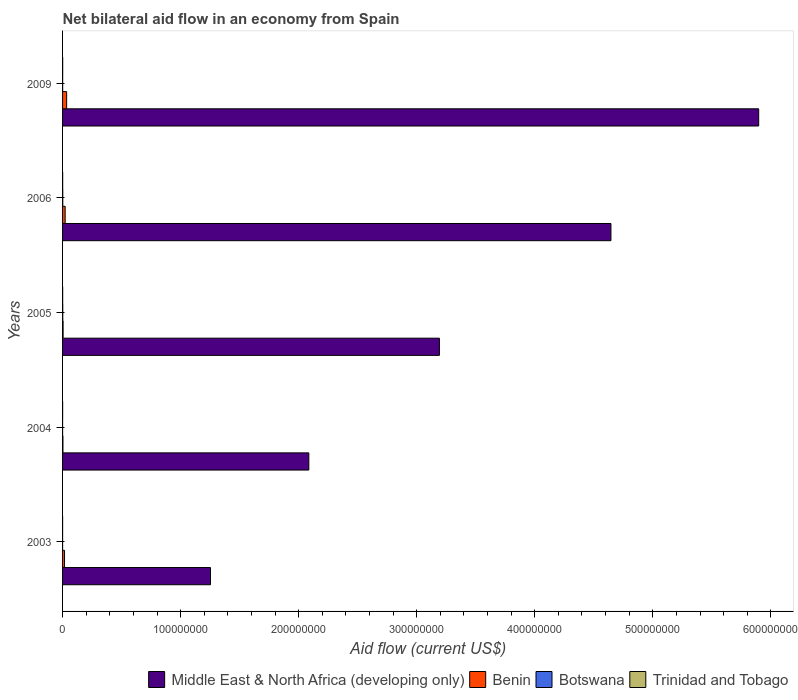How many different coloured bars are there?
Give a very brief answer. 4. How many bars are there on the 3rd tick from the bottom?
Ensure brevity in your answer.  4. What is the net bilateral aid flow in Middle East & North Africa (developing only) in 2003?
Give a very brief answer. 1.25e+08. Across all years, what is the maximum net bilateral aid flow in Botswana?
Your answer should be compact. 1.50e+05. Across all years, what is the minimum net bilateral aid flow in Middle East & North Africa (developing only)?
Give a very brief answer. 1.25e+08. In which year was the net bilateral aid flow in Benin maximum?
Keep it short and to the point. 2009. In which year was the net bilateral aid flow in Benin minimum?
Your answer should be very brief. 2004. What is the total net bilateral aid flow in Middle East & North Africa (developing only) in the graph?
Your answer should be very brief. 1.71e+09. What is the difference between the net bilateral aid flow in Trinidad and Tobago in 2009 and the net bilateral aid flow in Benin in 2003?
Offer a very short reply. -1.58e+06. What is the average net bilateral aid flow in Benin per year?
Provide a short and direct response. 1.61e+06. In the year 2009, what is the difference between the net bilateral aid flow in Middle East & North Africa (developing only) and net bilateral aid flow in Botswana?
Your answer should be compact. 5.90e+08. In how many years, is the net bilateral aid flow in Trinidad and Tobago greater than 360000000 US$?
Provide a short and direct response. 0. What is the ratio of the net bilateral aid flow in Middle East & North Africa (developing only) in 2003 to that in 2006?
Make the answer very short. 0.27. Is the difference between the net bilateral aid flow in Middle East & North Africa (developing only) in 2003 and 2009 greater than the difference between the net bilateral aid flow in Botswana in 2003 and 2009?
Provide a succinct answer. No. What is the difference between the highest and the lowest net bilateral aid flow in Trinidad and Tobago?
Keep it short and to the point. 6.00e+04. Is it the case that in every year, the sum of the net bilateral aid flow in Trinidad and Tobago and net bilateral aid flow in Botswana is greater than the sum of net bilateral aid flow in Middle East & North Africa (developing only) and net bilateral aid flow in Benin?
Ensure brevity in your answer.  No. What does the 2nd bar from the top in 2003 represents?
Provide a short and direct response. Botswana. What does the 2nd bar from the bottom in 2006 represents?
Your response must be concise. Benin. Is it the case that in every year, the sum of the net bilateral aid flow in Benin and net bilateral aid flow in Botswana is greater than the net bilateral aid flow in Trinidad and Tobago?
Offer a very short reply. Yes. What is the difference between two consecutive major ticks on the X-axis?
Your answer should be compact. 1.00e+08. Are the values on the major ticks of X-axis written in scientific E-notation?
Offer a terse response. No. Does the graph contain any zero values?
Offer a very short reply. No. Does the graph contain grids?
Offer a terse response. No. Where does the legend appear in the graph?
Provide a short and direct response. Bottom right. What is the title of the graph?
Offer a terse response. Net bilateral aid flow in an economy from Spain. Does "High income" appear as one of the legend labels in the graph?
Offer a terse response. No. What is the label or title of the X-axis?
Your answer should be very brief. Aid flow (current US$). What is the Aid flow (current US$) of Middle East & North Africa (developing only) in 2003?
Provide a succinct answer. 1.25e+08. What is the Aid flow (current US$) in Benin in 2003?
Keep it short and to the point. 1.67e+06. What is the Aid flow (current US$) of Botswana in 2003?
Keep it short and to the point. 10000. What is the Aid flow (current US$) of Trinidad and Tobago in 2003?
Provide a succinct answer. 3.00e+04. What is the Aid flow (current US$) in Middle East & North Africa (developing only) in 2004?
Provide a succinct answer. 2.09e+08. What is the Aid flow (current US$) in Botswana in 2004?
Provide a succinct answer. 10000. What is the Aid flow (current US$) of Middle East & North Africa (developing only) in 2005?
Offer a very short reply. 3.19e+08. What is the Aid flow (current US$) of Benin in 2005?
Make the answer very short. 4.50e+05. What is the Aid flow (current US$) in Botswana in 2005?
Offer a terse response. 1.50e+05. What is the Aid flow (current US$) of Trinidad and Tobago in 2005?
Offer a terse response. 7.00e+04. What is the Aid flow (current US$) in Middle East & North Africa (developing only) in 2006?
Your answer should be very brief. 4.65e+08. What is the Aid flow (current US$) in Benin in 2006?
Offer a very short reply. 2.19e+06. What is the Aid flow (current US$) of Trinidad and Tobago in 2006?
Keep it short and to the point. 7.00e+04. What is the Aid flow (current US$) of Middle East & North Africa (developing only) in 2009?
Your answer should be compact. 5.90e+08. What is the Aid flow (current US$) in Benin in 2009?
Ensure brevity in your answer.  3.45e+06. What is the Aid flow (current US$) of Trinidad and Tobago in 2009?
Give a very brief answer. 9.00e+04. Across all years, what is the maximum Aid flow (current US$) in Middle East & North Africa (developing only)?
Provide a succinct answer. 5.90e+08. Across all years, what is the maximum Aid flow (current US$) in Benin?
Your answer should be compact. 3.45e+06. Across all years, what is the maximum Aid flow (current US$) in Botswana?
Offer a very short reply. 1.50e+05. Across all years, what is the maximum Aid flow (current US$) in Trinidad and Tobago?
Give a very brief answer. 9.00e+04. Across all years, what is the minimum Aid flow (current US$) of Middle East & North Africa (developing only)?
Provide a short and direct response. 1.25e+08. What is the total Aid flow (current US$) of Middle East & North Africa (developing only) in the graph?
Offer a terse response. 1.71e+09. What is the total Aid flow (current US$) in Benin in the graph?
Make the answer very short. 8.07e+06. What is the total Aid flow (current US$) in Botswana in the graph?
Make the answer very short. 3.80e+05. What is the difference between the Aid flow (current US$) in Middle East & North Africa (developing only) in 2003 and that in 2004?
Make the answer very short. -8.33e+07. What is the difference between the Aid flow (current US$) of Benin in 2003 and that in 2004?
Make the answer very short. 1.36e+06. What is the difference between the Aid flow (current US$) in Botswana in 2003 and that in 2004?
Offer a very short reply. 0. What is the difference between the Aid flow (current US$) in Middle East & North Africa (developing only) in 2003 and that in 2005?
Offer a very short reply. -1.94e+08. What is the difference between the Aid flow (current US$) in Benin in 2003 and that in 2005?
Keep it short and to the point. 1.22e+06. What is the difference between the Aid flow (current US$) of Botswana in 2003 and that in 2005?
Provide a short and direct response. -1.40e+05. What is the difference between the Aid flow (current US$) of Trinidad and Tobago in 2003 and that in 2005?
Ensure brevity in your answer.  -4.00e+04. What is the difference between the Aid flow (current US$) of Middle East & North Africa (developing only) in 2003 and that in 2006?
Give a very brief answer. -3.39e+08. What is the difference between the Aid flow (current US$) in Benin in 2003 and that in 2006?
Offer a very short reply. -5.20e+05. What is the difference between the Aid flow (current US$) in Botswana in 2003 and that in 2006?
Your answer should be compact. -1.40e+05. What is the difference between the Aid flow (current US$) of Trinidad and Tobago in 2003 and that in 2006?
Your answer should be compact. -4.00e+04. What is the difference between the Aid flow (current US$) in Middle East & North Africa (developing only) in 2003 and that in 2009?
Your response must be concise. -4.64e+08. What is the difference between the Aid flow (current US$) in Benin in 2003 and that in 2009?
Keep it short and to the point. -1.78e+06. What is the difference between the Aid flow (current US$) in Botswana in 2003 and that in 2009?
Provide a short and direct response. -5.00e+04. What is the difference between the Aid flow (current US$) of Trinidad and Tobago in 2003 and that in 2009?
Keep it short and to the point. -6.00e+04. What is the difference between the Aid flow (current US$) of Middle East & North Africa (developing only) in 2004 and that in 2005?
Provide a short and direct response. -1.11e+08. What is the difference between the Aid flow (current US$) of Benin in 2004 and that in 2005?
Provide a succinct answer. -1.40e+05. What is the difference between the Aid flow (current US$) of Botswana in 2004 and that in 2005?
Keep it short and to the point. -1.40e+05. What is the difference between the Aid flow (current US$) of Trinidad and Tobago in 2004 and that in 2005?
Your answer should be very brief. -2.00e+04. What is the difference between the Aid flow (current US$) of Middle East & North Africa (developing only) in 2004 and that in 2006?
Offer a terse response. -2.56e+08. What is the difference between the Aid flow (current US$) of Benin in 2004 and that in 2006?
Your response must be concise. -1.88e+06. What is the difference between the Aid flow (current US$) in Botswana in 2004 and that in 2006?
Ensure brevity in your answer.  -1.40e+05. What is the difference between the Aid flow (current US$) in Trinidad and Tobago in 2004 and that in 2006?
Offer a very short reply. -2.00e+04. What is the difference between the Aid flow (current US$) of Middle East & North Africa (developing only) in 2004 and that in 2009?
Your response must be concise. -3.81e+08. What is the difference between the Aid flow (current US$) of Benin in 2004 and that in 2009?
Offer a terse response. -3.14e+06. What is the difference between the Aid flow (current US$) in Middle East & North Africa (developing only) in 2005 and that in 2006?
Keep it short and to the point. -1.45e+08. What is the difference between the Aid flow (current US$) of Benin in 2005 and that in 2006?
Give a very brief answer. -1.74e+06. What is the difference between the Aid flow (current US$) in Botswana in 2005 and that in 2006?
Your answer should be very brief. 0. What is the difference between the Aid flow (current US$) of Trinidad and Tobago in 2005 and that in 2006?
Provide a short and direct response. 0. What is the difference between the Aid flow (current US$) in Middle East & North Africa (developing only) in 2005 and that in 2009?
Ensure brevity in your answer.  -2.70e+08. What is the difference between the Aid flow (current US$) in Botswana in 2005 and that in 2009?
Keep it short and to the point. 9.00e+04. What is the difference between the Aid flow (current US$) in Trinidad and Tobago in 2005 and that in 2009?
Provide a succinct answer. -2.00e+04. What is the difference between the Aid flow (current US$) of Middle East & North Africa (developing only) in 2006 and that in 2009?
Give a very brief answer. -1.25e+08. What is the difference between the Aid flow (current US$) in Benin in 2006 and that in 2009?
Offer a terse response. -1.26e+06. What is the difference between the Aid flow (current US$) of Middle East & North Africa (developing only) in 2003 and the Aid flow (current US$) of Benin in 2004?
Offer a terse response. 1.25e+08. What is the difference between the Aid flow (current US$) in Middle East & North Africa (developing only) in 2003 and the Aid flow (current US$) in Botswana in 2004?
Offer a terse response. 1.25e+08. What is the difference between the Aid flow (current US$) of Middle East & North Africa (developing only) in 2003 and the Aid flow (current US$) of Trinidad and Tobago in 2004?
Offer a terse response. 1.25e+08. What is the difference between the Aid flow (current US$) of Benin in 2003 and the Aid flow (current US$) of Botswana in 2004?
Ensure brevity in your answer.  1.66e+06. What is the difference between the Aid flow (current US$) in Benin in 2003 and the Aid flow (current US$) in Trinidad and Tobago in 2004?
Provide a succinct answer. 1.62e+06. What is the difference between the Aid flow (current US$) of Middle East & North Africa (developing only) in 2003 and the Aid flow (current US$) of Benin in 2005?
Offer a terse response. 1.25e+08. What is the difference between the Aid flow (current US$) in Middle East & North Africa (developing only) in 2003 and the Aid flow (current US$) in Botswana in 2005?
Make the answer very short. 1.25e+08. What is the difference between the Aid flow (current US$) in Middle East & North Africa (developing only) in 2003 and the Aid flow (current US$) in Trinidad and Tobago in 2005?
Offer a terse response. 1.25e+08. What is the difference between the Aid flow (current US$) in Benin in 2003 and the Aid flow (current US$) in Botswana in 2005?
Provide a succinct answer. 1.52e+06. What is the difference between the Aid flow (current US$) of Benin in 2003 and the Aid flow (current US$) of Trinidad and Tobago in 2005?
Your answer should be compact. 1.60e+06. What is the difference between the Aid flow (current US$) of Middle East & North Africa (developing only) in 2003 and the Aid flow (current US$) of Benin in 2006?
Your response must be concise. 1.23e+08. What is the difference between the Aid flow (current US$) in Middle East & North Africa (developing only) in 2003 and the Aid flow (current US$) in Botswana in 2006?
Give a very brief answer. 1.25e+08. What is the difference between the Aid flow (current US$) in Middle East & North Africa (developing only) in 2003 and the Aid flow (current US$) in Trinidad and Tobago in 2006?
Provide a succinct answer. 1.25e+08. What is the difference between the Aid flow (current US$) in Benin in 2003 and the Aid flow (current US$) in Botswana in 2006?
Keep it short and to the point. 1.52e+06. What is the difference between the Aid flow (current US$) in Benin in 2003 and the Aid flow (current US$) in Trinidad and Tobago in 2006?
Offer a very short reply. 1.60e+06. What is the difference between the Aid flow (current US$) in Botswana in 2003 and the Aid flow (current US$) in Trinidad and Tobago in 2006?
Provide a short and direct response. -6.00e+04. What is the difference between the Aid flow (current US$) in Middle East & North Africa (developing only) in 2003 and the Aid flow (current US$) in Benin in 2009?
Offer a very short reply. 1.22e+08. What is the difference between the Aid flow (current US$) of Middle East & North Africa (developing only) in 2003 and the Aid flow (current US$) of Botswana in 2009?
Provide a short and direct response. 1.25e+08. What is the difference between the Aid flow (current US$) in Middle East & North Africa (developing only) in 2003 and the Aid flow (current US$) in Trinidad and Tobago in 2009?
Offer a terse response. 1.25e+08. What is the difference between the Aid flow (current US$) of Benin in 2003 and the Aid flow (current US$) of Botswana in 2009?
Offer a terse response. 1.61e+06. What is the difference between the Aid flow (current US$) in Benin in 2003 and the Aid flow (current US$) in Trinidad and Tobago in 2009?
Offer a terse response. 1.58e+06. What is the difference between the Aid flow (current US$) of Middle East & North Africa (developing only) in 2004 and the Aid flow (current US$) of Benin in 2005?
Provide a succinct answer. 2.08e+08. What is the difference between the Aid flow (current US$) in Middle East & North Africa (developing only) in 2004 and the Aid flow (current US$) in Botswana in 2005?
Provide a short and direct response. 2.08e+08. What is the difference between the Aid flow (current US$) of Middle East & North Africa (developing only) in 2004 and the Aid flow (current US$) of Trinidad and Tobago in 2005?
Provide a succinct answer. 2.09e+08. What is the difference between the Aid flow (current US$) of Benin in 2004 and the Aid flow (current US$) of Trinidad and Tobago in 2005?
Offer a terse response. 2.40e+05. What is the difference between the Aid flow (current US$) of Middle East & North Africa (developing only) in 2004 and the Aid flow (current US$) of Benin in 2006?
Offer a terse response. 2.06e+08. What is the difference between the Aid flow (current US$) in Middle East & North Africa (developing only) in 2004 and the Aid flow (current US$) in Botswana in 2006?
Provide a succinct answer. 2.08e+08. What is the difference between the Aid flow (current US$) in Middle East & North Africa (developing only) in 2004 and the Aid flow (current US$) in Trinidad and Tobago in 2006?
Your answer should be very brief. 2.09e+08. What is the difference between the Aid flow (current US$) of Benin in 2004 and the Aid flow (current US$) of Trinidad and Tobago in 2006?
Offer a terse response. 2.40e+05. What is the difference between the Aid flow (current US$) of Botswana in 2004 and the Aid flow (current US$) of Trinidad and Tobago in 2006?
Give a very brief answer. -6.00e+04. What is the difference between the Aid flow (current US$) of Middle East & North Africa (developing only) in 2004 and the Aid flow (current US$) of Benin in 2009?
Provide a short and direct response. 2.05e+08. What is the difference between the Aid flow (current US$) of Middle East & North Africa (developing only) in 2004 and the Aid flow (current US$) of Botswana in 2009?
Keep it short and to the point. 2.09e+08. What is the difference between the Aid flow (current US$) in Middle East & North Africa (developing only) in 2004 and the Aid flow (current US$) in Trinidad and Tobago in 2009?
Provide a succinct answer. 2.09e+08. What is the difference between the Aid flow (current US$) in Middle East & North Africa (developing only) in 2005 and the Aid flow (current US$) in Benin in 2006?
Keep it short and to the point. 3.17e+08. What is the difference between the Aid flow (current US$) of Middle East & North Africa (developing only) in 2005 and the Aid flow (current US$) of Botswana in 2006?
Provide a succinct answer. 3.19e+08. What is the difference between the Aid flow (current US$) of Middle East & North Africa (developing only) in 2005 and the Aid flow (current US$) of Trinidad and Tobago in 2006?
Your answer should be very brief. 3.19e+08. What is the difference between the Aid flow (current US$) of Benin in 2005 and the Aid flow (current US$) of Trinidad and Tobago in 2006?
Provide a short and direct response. 3.80e+05. What is the difference between the Aid flow (current US$) in Middle East & North Africa (developing only) in 2005 and the Aid flow (current US$) in Benin in 2009?
Ensure brevity in your answer.  3.16e+08. What is the difference between the Aid flow (current US$) in Middle East & North Africa (developing only) in 2005 and the Aid flow (current US$) in Botswana in 2009?
Ensure brevity in your answer.  3.19e+08. What is the difference between the Aid flow (current US$) in Middle East & North Africa (developing only) in 2005 and the Aid flow (current US$) in Trinidad and Tobago in 2009?
Your answer should be very brief. 3.19e+08. What is the difference between the Aid flow (current US$) in Benin in 2005 and the Aid flow (current US$) in Botswana in 2009?
Provide a succinct answer. 3.90e+05. What is the difference between the Aid flow (current US$) in Benin in 2005 and the Aid flow (current US$) in Trinidad and Tobago in 2009?
Keep it short and to the point. 3.60e+05. What is the difference between the Aid flow (current US$) of Middle East & North Africa (developing only) in 2006 and the Aid flow (current US$) of Benin in 2009?
Ensure brevity in your answer.  4.61e+08. What is the difference between the Aid flow (current US$) of Middle East & North Africa (developing only) in 2006 and the Aid flow (current US$) of Botswana in 2009?
Make the answer very short. 4.64e+08. What is the difference between the Aid flow (current US$) in Middle East & North Africa (developing only) in 2006 and the Aid flow (current US$) in Trinidad and Tobago in 2009?
Your answer should be compact. 4.64e+08. What is the difference between the Aid flow (current US$) of Benin in 2006 and the Aid flow (current US$) of Botswana in 2009?
Provide a short and direct response. 2.13e+06. What is the difference between the Aid flow (current US$) of Benin in 2006 and the Aid flow (current US$) of Trinidad and Tobago in 2009?
Keep it short and to the point. 2.10e+06. What is the average Aid flow (current US$) of Middle East & North Africa (developing only) per year?
Offer a terse response. 3.41e+08. What is the average Aid flow (current US$) in Benin per year?
Your answer should be compact. 1.61e+06. What is the average Aid flow (current US$) of Botswana per year?
Offer a very short reply. 7.60e+04. What is the average Aid flow (current US$) of Trinidad and Tobago per year?
Your response must be concise. 6.20e+04. In the year 2003, what is the difference between the Aid flow (current US$) of Middle East & North Africa (developing only) and Aid flow (current US$) of Benin?
Make the answer very short. 1.24e+08. In the year 2003, what is the difference between the Aid flow (current US$) of Middle East & North Africa (developing only) and Aid flow (current US$) of Botswana?
Give a very brief answer. 1.25e+08. In the year 2003, what is the difference between the Aid flow (current US$) of Middle East & North Africa (developing only) and Aid flow (current US$) of Trinidad and Tobago?
Your answer should be compact. 1.25e+08. In the year 2003, what is the difference between the Aid flow (current US$) in Benin and Aid flow (current US$) in Botswana?
Ensure brevity in your answer.  1.66e+06. In the year 2003, what is the difference between the Aid flow (current US$) in Benin and Aid flow (current US$) in Trinidad and Tobago?
Give a very brief answer. 1.64e+06. In the year 2003, what is the difference between the Aid flow (current US$) in Botswana and Aid flow (current US$) in Trinidad and Tobago?
Make the answer very short. -2.00e+04. In the year 2004, what is the difference between the Aid flow (current US$) of Middle East & North Africa (developing only) and Aid flow (current US$) of Benin?
Your response must be concise. 2.08e+08. In the year 2004, what is the difference between the Aid flow (current US$) in Middle East & North Africa (developing only) and Aid flow (current US$) in Botswana?
Keep it short and to the point. 2.09e+08. In the year 2004, what is the difference between the Aid flow (current US$) in Middle East & North Africa (developing only) and Aid flow (current US$) in Trinidad and Tobago?
Your response must be concise. 2.09e+08. In the year 2004, what is the difference between the Aid flow (current US$) of Benin and Aid flow (current US$) of Botswana?
Give a very brief answer. 3.00e+05. In the year 2004, what is the difference between the Aid flow (current US$) in Benin and Aid flow (current US$) in Trinidad and Tobago?
Your answer should be compact. 2.60e+05. In the year 2004, what is the difference between the Aid flow (current US$) in Botswana and Aid flow (current US$) in Trinidad and Tobago?
Your response must be concise. -4.00e+04. In the year 2005, what is the difference between the Aid flow (current US$) in Middle East & North Africa (developing only) and Aid flow (current US$) in Benin?
Keep it short and to the point. 3.19e+08. In the year 2005, what is the difference between the Aid flow (current US$) of Middle East & North Africa (developing only) and Aid flow (current US$) of Botswana?
Your response must be concise. 3.19e+08. In the year 2005, what is the difference between the Aid flow (current US$) in Middle East & North Africa (developing only) and Aid flow (current US$) in Trinidad and Tobago?
Keep it short and to the point. 3.19e+08. In the year 2005, what is the difference between the Aid flow (current US$) in Benin and Aid flow (current US$) in Botswana?
Your answer should be compact. 3.00e+05. In the year 2006, what is the difference between the Aid flow (current US$) of Middle East & North Africa (developing only) and Aid flow (current US$) of Benin?
Make the answer very short. 4.62e+08. In the year 2006, what is the difference between the Aid flow (current US$) in Middle East & North Africa (developing only) and Aid flow (current US$) in Botswana?
Provide a short and direct response. 4.64e+08. In the year 2006, what is the difference between the Aid flow (current US$) of Middle East & North Africa (developing only) and Aid flow (current US$) of Trinidad and Tobago?
Provide a short and direct response. 4.64e+08. In the year 2006, what is the difference between the Aid flow (current US$) of Benin and Aid flow (current US$) of Botswana?
Ensure brevity in your answer.  2.04e+06. In the year 2006, what is the difference between the Aid flow (current US$) in Benin and Aid flow (current US$) in Trinidad and Tobago?
Give a very brief answer. 2.12e+06. In the year 2009, what is the difference between the Aid flow (current US$) in Middle East & North Africa (developing only) and Aid flow (current US$) in Benin?
Your response must be concise. 5.86e+08. In the year 2009, what is the difference between the Aid flow (current US$) of Middle East & North Africa (developing only) and Aid flow (current US$) of Botswana?
Give a very brief answer. 5.90e+08. In the year 2009, what is the difference between the Aid flow (current US$) of Middle East & North Africa (developing only) and Aid flow (current US$) of Trinidad and Tobago?
Ensure brevity in your answer.  5.90e+08. In the year 2009, what is the difference between the Aid flow (current US$) of Benin and Aid flow (current US$) of Botswana?
Offer a very short reply. 3.39e+06. In the year 2009, what is the difference between the Aid flow (current US$) in Benin and Aid flow (current US$) in Trinidad and Tobago?
Your answer should be very brief. 3.36e+06. In the year 2009, what is the difference between the Aid flow (current US$) in Botswana and Aid flow (current US$) in Trinidad and Tobago?
Offer a terse response. -3.00e+04. What is the ratio of the Aid flow (current US$) in Middle East & North Africa (developing only) in 2003 to that in 2004?
Your answer should be very brief. 0.6. What is the ratio of the Aid flow (current US$) in Benin in 2003 to that in 2004?
Provide a short and direct response. 5.39. What is the ratio of the Aid flow (current US$) of Botswana in 2003 to that in 2004?
Your response must be concise. 1. What is the ratio of the Aid flow (current US$) in Middle East & North Africa (developing only) in 2003 to that in 2005?
Your answer should be very brief. 0.39. What is the ratio of the Aid flow (current US$) in Benin in 2003 to that in 2005?
Offer a terse response. 3.71. What is the ratio of the Aid flow (current US$) of Botswana in 2003 to that in 2005?
Your response must be concise. 0.07. What is the ratio of the Aid flow (current US$) of Trinidad and Tobago in 2003 to that in 2005?
Offer a terse response. 0.43. What is the ratio of the Aid flow (current US$) of Middle East & North Africa (developing only) in 2003 to that in 2006?
Keep it short and to the point. 0.27. What is the ratio of the Aid flow (current US$) of Benin in 2003 to that in 2006?
Your answer should be very brief. 0.76. What is the ratio of the Aid flow (current US$) in Botswana in 2003 to that in 2006?
Your answer should be compact. 0.07. What is the ratio of the Aid flow (current US$) of Trinidad and Tobago in 2003 to that in 2006?
Make the answer very short. 0.43. What is the ratio of the Aid flow (current US$) of Middle East & North Africa (developing only) in 2003 to that in 2009?
Provide a short and direct response. 0.21. What is the ratio of the Aid flow (current US$) in Benin in 2003 to that in 2009?
Your answer should be very brief. 0.48. What is the ratio of the Aid flow (current US$) in Botswana in 2003 to that in 2009?
Give a very brief answer. 0.17. What is the ratio of the Aid flow (current US$) of Trinidad and Tobago in 2003 to that in 2009?
Give a very brief answer. 0.33. What is the ratio of the Aid flow (current US$) of Middle East & North Africa (developing only) in 2004 to that in 2005?
Offer a very short reply. 0.65. What is the ratio of the Aid flow (current US$) of Benin in 2004 to that in 2005?
Provide a short and direct response. 0.69. What is the ratio of the Aid flow (current US$) of Botswana in 2004 to that in 2005?
Offer a very short reply. 0.07. What is the ratio of the Aid flow (current US$) of Trinidad and Tobago in 2004 to that in 2005?
Give a very brief answer. 0.71. What is the ratio of the Aid flow (current US$) in Middle East & North Africa (developing only) in 2004 to that in 2006?
Provide a short and direct response. 0.45. What is the ratio of the Aid flow (current US$) of Benin in 2004 to that in 2006?
Offer a very short reply. 0.14. What is the ratio of the Aid flow (current US$) in Botswana in 2004 to that in 2006?
Your response must be concise. 0.07. What is the ratio of the Aid flow (current US$) of Trinidad and Tobago in 2004 to that in 2006?
Give a very brief answer. 0.71. What is the ratio of the Aid flow (current US$) of Middle East & North Africa (developing only) in 2004 to that in 2009?
Your answer should be compact. 0.35. What is the ratio of the Aid flow (current US$) in Benin in 2004 to that in 2009?
Offer a terse response. 0.09. What is the ratio of the Aid flow (current US$) of Botswana in 2004 to that in 2009?
Your answer should be compact. 0.17. What is the ratio of the Aid flow (current US$) of Trinidad and Tobago in 2004 to that in 2009?
Make the answer very short. 0.56. What is the ratio of the Aid flow (current US$) of Middle East & North Africa (developing only) in 2005 to that in 2006?
Provide a succinct answer. 0.69. What is the ratio of the Aid flow (current US$) of Benin in 2005 to that in 2006?
Offer a terse response. 0.21. What is the ratio of the Aid flow (current US$) of Trinidad and Tobago in 2005 to that in 2006?
Offer a terse response. 1. What is the ratio of the Aid flow (current US$) in Middle East & North Africa (developing only) in 2005 to that in 2009?
Your answer should be compact. 0.54. What is the ratio of the Aid flow (current US$) of Benin in 2005 to that in 2009?
Make the answer very short. 0.13. What is the ratio of the Aid flow (current US$) in Botswana in 2005 to that in 2009?
Your answer should be very brief. 2.5. What is the ratio of the Aid flow (current US$) in Trinidad and Tobago in 2005 to that in 2009?
Provide a succinct answer. 0.78. What is the ratio of the Aid flow (current US$) of Middle East & North Africa (developing only) in 2006 to that in 2009?
Provide a short and direct response. 0.79. What is the ratio of the Aid flow (current US$) of Benin in 2006 to that in 2009?
Keep it short and to the point. 0.63. What is the ratio of the Aid flow (current US$) in Trinidad and Tobago in 2006 to that in 2009?
Provide a succinct answer. 0.78. What is the difference between the highest and the second highest Aid flow (current US$) in Middle East & North Africa (developing only)?
Give a very brief answer. 1.25e+08. What is the difference between the highest and the second highest Aid flow (current US$) of Benin?
Provide a short and direct response. 1.26e+06. What is the difference between the highest and the lowest Aid flow (current US$) of Middle East & North Africa (developing only)?
Give a very brief answer. 4.64e+08. What is the difference between the highest and the lowest Aid flow (current US$) of Benin?
Make the answer very short. 3.14e+06. 